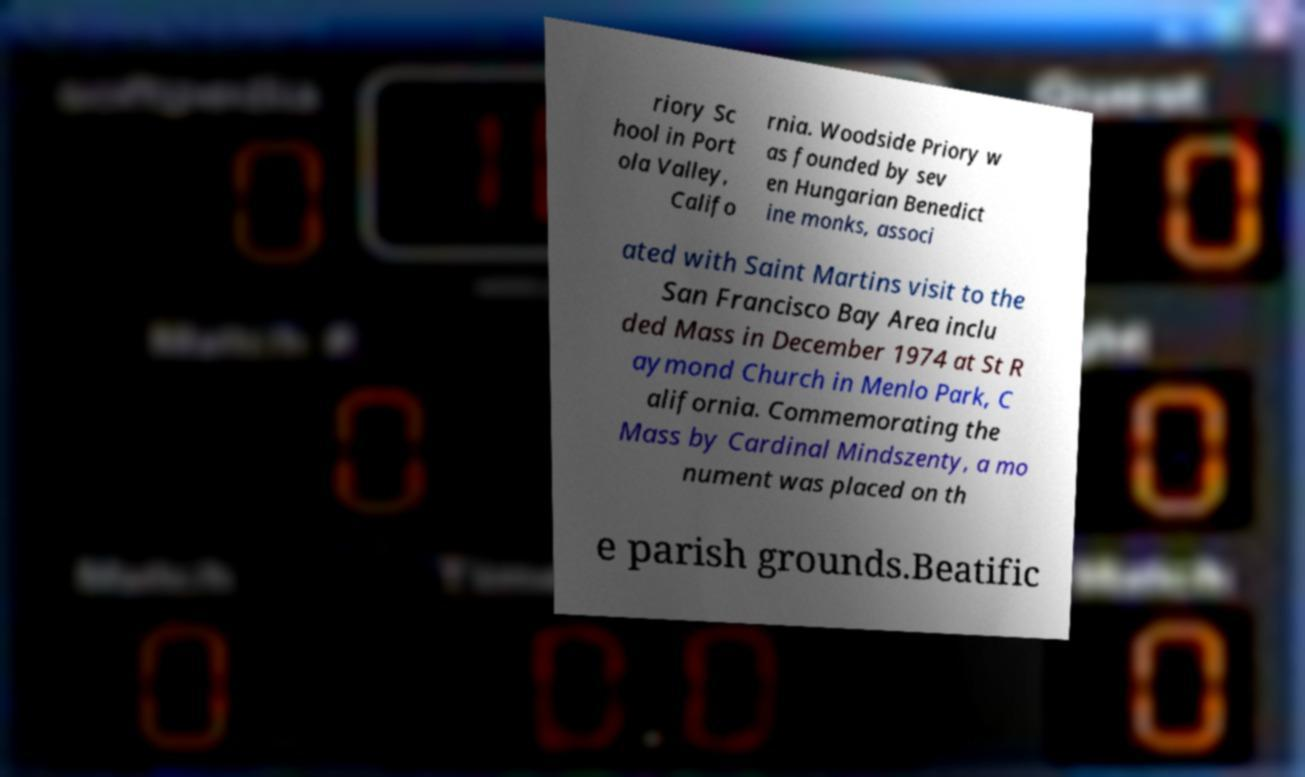For documentation purposes, I need the text within this image transcribed. Could you provide that? riory Sc hool in Port ola Valley, Califo rnia. Woodside Priory w as founded by sev en Hungarian Benedict ine monks, associ ated with Saint Martins visit to the San Francisco Bay Area inclu ded Mass in December 1974 at St R aymond Church in Menlo Park, C alifornia. Commemorating the Mass by Cardinal Mindszenty, a mo nument was placed on th e parish grounds.Beatific 